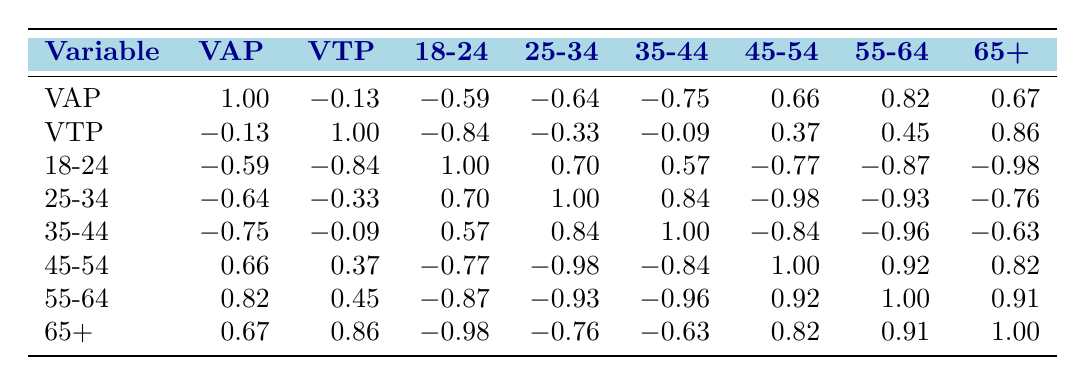What is the voter turnout percentage for Los Angeles? The table indicates the voter turnout percentage for Los Angeles as 48.
Answer: 48 Which city has the highest percentage of 18-24-year-olds? In the table, Los Angeles has the highest percentage of 18-24-year-olds at 15 percent.
Answer: 15 What is the correlation between the 45-54 age demographic and voter turnout? The correlation coefficient between the 45-54 age demographic and voter turnout is 0.37, indicating a weak positive correlation.
Answer: 0.37 What is the average voter turnout percentage across all cities? To find the average, sum the voter turnout percentages (55 + 48 + 62 + 55 + 52 = 272) and divide by the number of cities (5). The average is 272/5 = 54.4.
Answer: 54.4 Is the statement "Older voters (65 and over) have the highest correlation with voter turnout" true or false? The correlation with older voters (65+) is 0.86, which is the highest among all demographics, making the statement true.
Answer: True What is the correlation between the demographic aged 25-34 and the demographic aged 35-44? The correlation coefficient between these two demographics is 0.84, suggesting a strong positive correlation.
Answer: 0.84 Which demographic age group has the highest negative correlation with voter turnout? The 18-24 age group has the highest negative correlation with voter turnout at -0.84, indicating a strong inverse relationship.
Answer: -0.84 If we consider the voter turnout of 62% in Chicago, what is the difference in turnout compared to New York's 55%? The difference in voter turnout is calculated as 62 - 55 = 7, indicating that Chicago's voter turnout is higher by 7 percentage points.
Answer: 7 What is the correlation between the voting age population and the demographic aged 55-64? The correlation coefficient between the voting age population and the demographic aged 55-64 is 0.82, indicating a strong positive correlation.
Answer: 0.82 